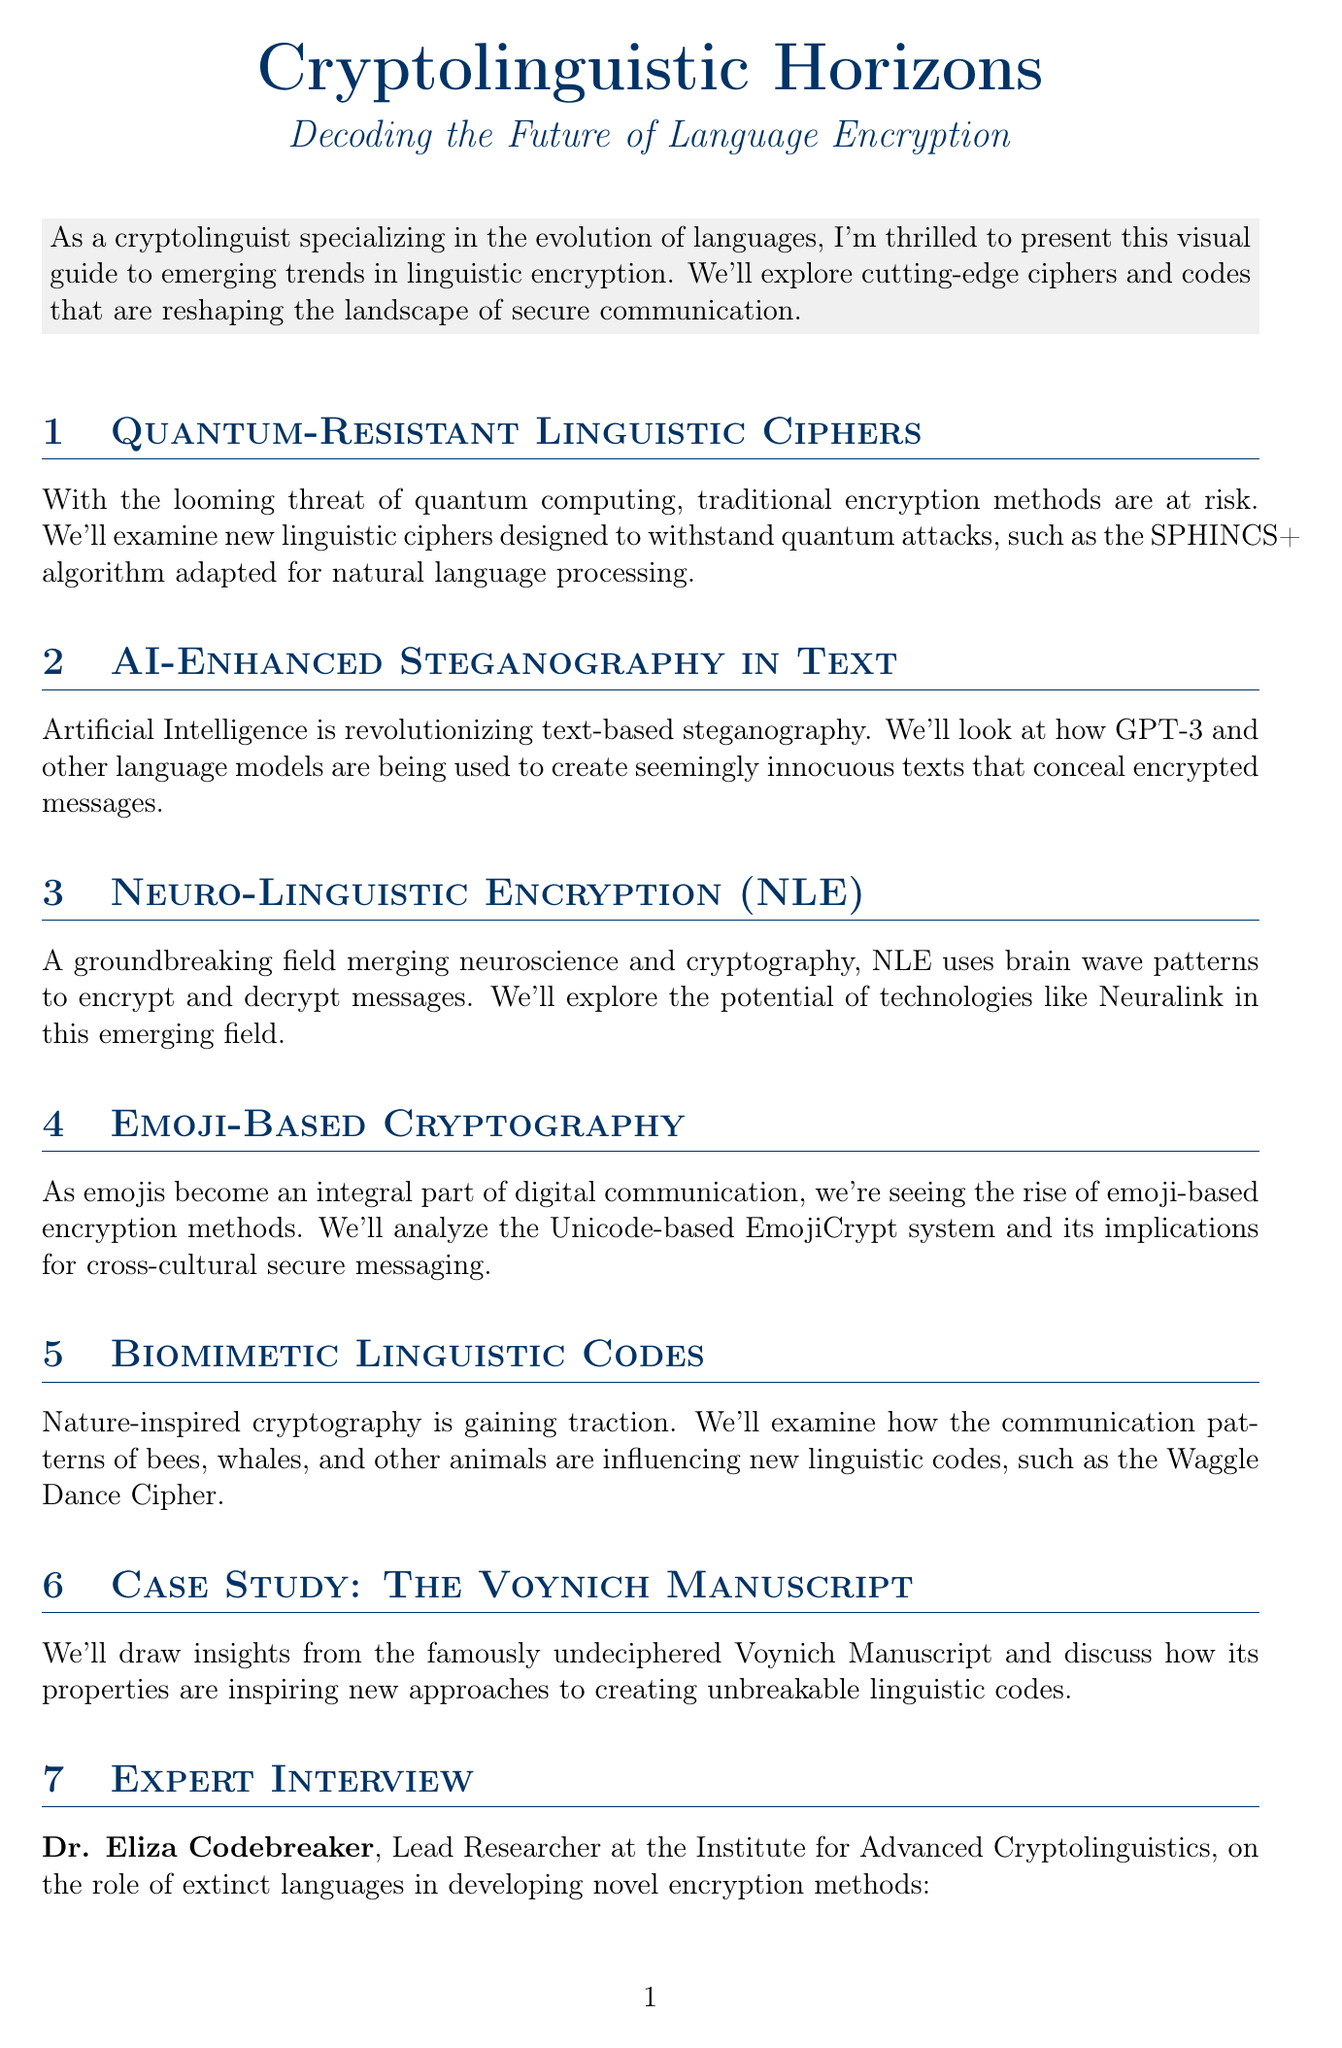What is the title of the newsletter? The title is found at the beginning of the document, explicitly stating the subject.
Answer: Cryptolinguistic Horizons: Decoding the Future of Language Encryption Who is the lead researcher mentioned in the expert interview? The expert interview section provides the name and title of the researcher.
Answer: Dr. Eliza Codebreaker What technology does Neuro-Linguistic Encryption (NLE) use? The document mentions a specific technology linked to NLE within its description.
Answer: Brain wave patterns What is the date of the International Symposium on Linguistic Cryptography? This date can be found in the upcoming events section, listing the event and its timeframe.
Answer: October 15-17, 2023 Which algorithm is adapted for natural language processing to withstand quantum attacks? The specific algorithm is mentioned in the section discussing quantum-resistant linguistic ciphers.
Answer: SPHINCS+ What animal's communication patterns are discussed in the context of biomimetic linguistic codes? The document identifies various animals whose communication influences cryptography.
Answer: Bees, whales What is the visual element accompanying the section on AI-Enhanced Steganography? Each section includes a visual element, specifically stated for the steganography section.
Answer: Flowchart of AI-driven steganographic process What is the focus of the upcoming workshop on November 5, 2023? The title in the events section specifies what the workshop will address.
Answer: Quantum-Resistant Language Models 